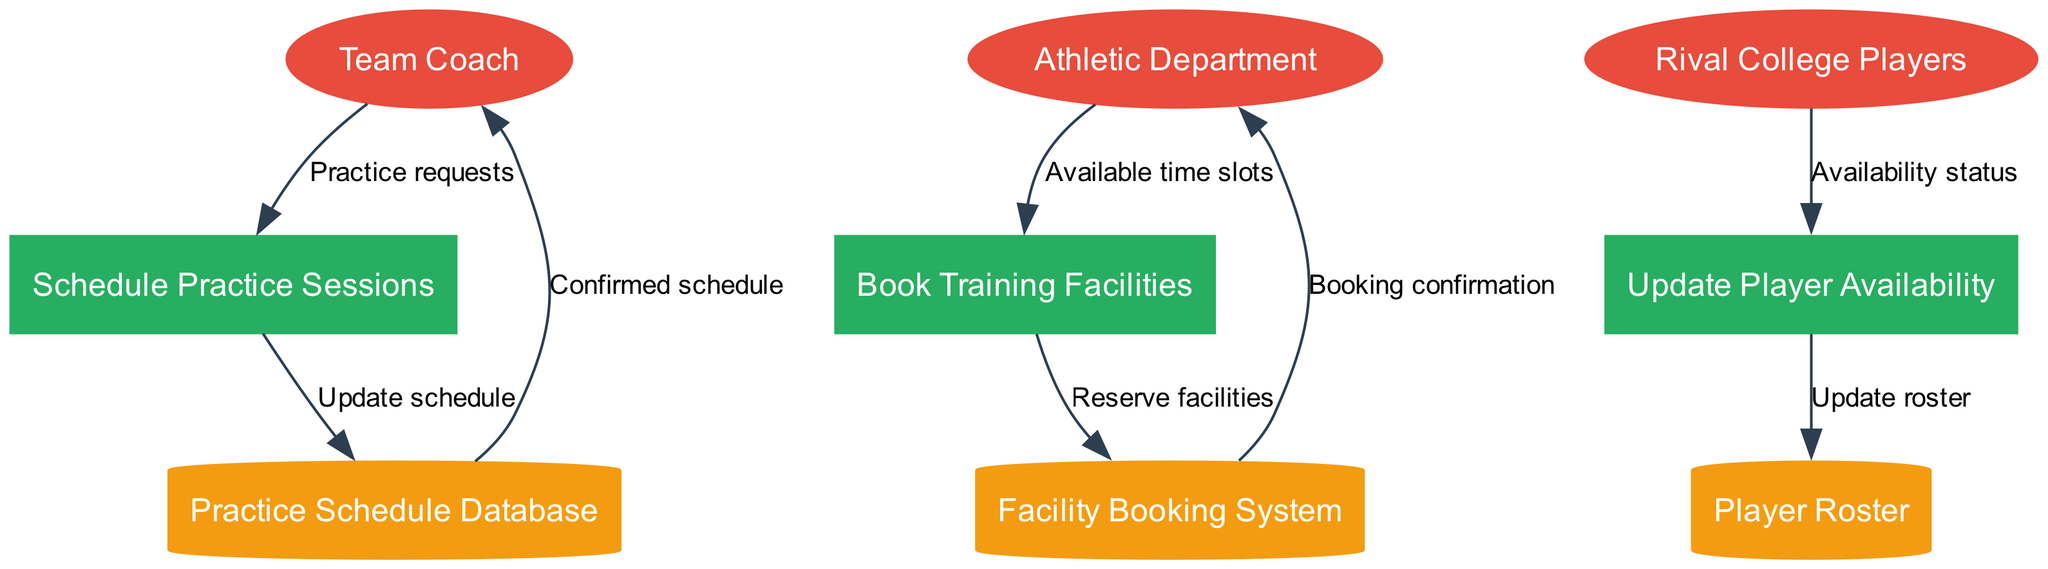What are the external entities in the diagram? The diagram lists three external entities: Team Coach, Athletic Department, and Rival College Players. Each of these represents a party that interacts with the processes in the system.
Answer: Team Coach, Athletic Department, Rival College Players How many processes are represented in the diagram? The diagram indicates there are three distinct processes: Schedule Practice Sessions, Book Training Facilities, and Update Player Availability. Counting these gives us the total number of processes.
Answer: 3 Which process does the Team Coach interact with? The Team Coach sends Practice requests to the process named Schedule Practice Sessions. This interaction indicates their role in the practice scheduling system.
Answer: Schedule Practice Sessions What data flows from the Facility Booking System to the Athletic Department? The edge labeled "Booking confirmation" flows from the Facility Booking System to the Athletic Department. This data flow represents the confirmation of facility bookings.
Answer: Booking confirmation Which data store receives an update from the Update Player Availability process? The Update Player Availability process contributes to updates in the Player Roster data store. This means player availability changes are recorded in the roster.
Answer: Player Roster What type of data does the Athletic Department provide to the Book Training Facilities process? The data from the Athletic Department to the Book Training Facilities process consists of Available time slots. This shows the scheduling capabilities provided by the Athletic Department.
Answer: Available time slots Which process updates the Practice Schedule Database? The process that updates the Practice Schedule Database is Schedule Practice Sessions, which takes the Practice requests and manages the schedule accordingly.
Answer: Schedule Practice Sessions How many data stores are mentioned in the diagram? The diagram has three data stores: Practice Schedule Database, Facility Booking System, and Player Roster. Adding these gives the total number of stores.
Answer: 3 What is the final output of data from the Practice Schedule Database to the Team Coach? The final output from the Practice Schedule Database to the Team Coach is labeled as Confirmed schedule, indicating the team coach receives the updated schedule after processing.
Answer: Confirmed schedule 